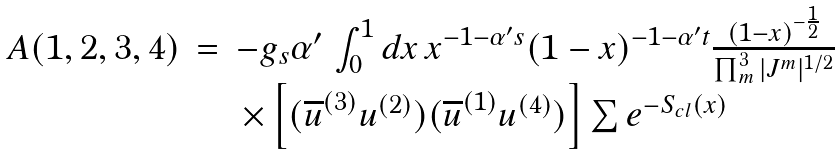Convert formula to latex. <formula><loc_0><loc_0><loc_500><loc_500>\begin{array} { l l l } A ( 1 , 2 , 3 , 4 ) & = & - g _ { s } \alpha ^ { \prime } \, \int _ { 0 } ^ { 1 } d x \, x ^ { - 1 - \alpha ^ { \prime } s } ( 1 - x ) ^ { - 1 - \alpha ^ { \prime } t } \frac { ( 1 - x ) ^ { - \frac { 1 } { 2 } } } { \prod _ { m } ^ { 3 } | J ^ { m } | ^ { 1 / 2 } } \\ & & \, \times \left [ ( \overline { u } ^ { ( 3 ) } u ^ { ( 2 ) } ) ( \overline { u } ^ { ( 1 ) } u ^ { ( 4 ) } ) \right ] \sum e ^ { - S _ { c l } ( x ) } \end{array}</formula> 